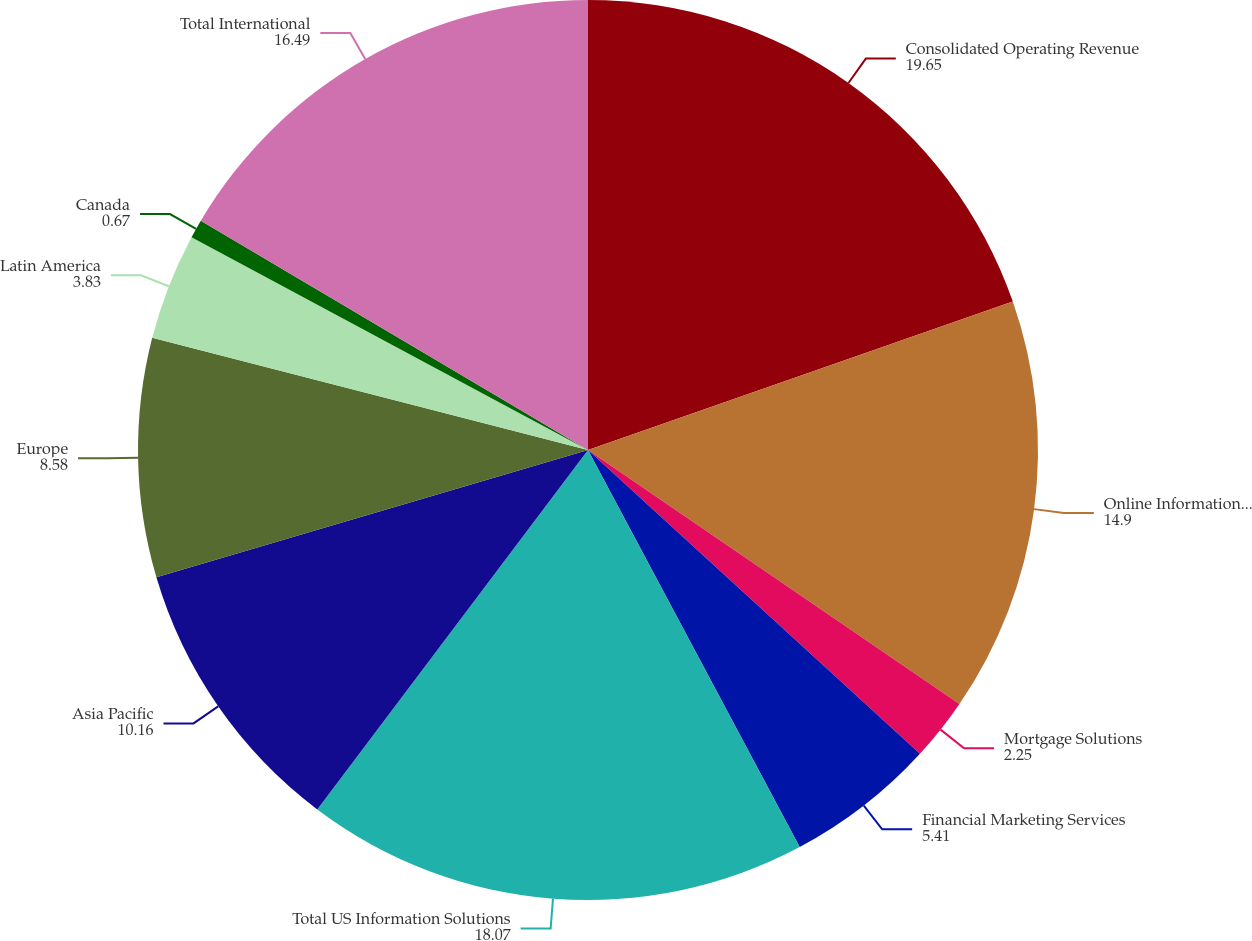Convert chart to OTSL. <chart><loc_0><loc_0><loc_500><loc_500><pie_chart><fcel>Consolidated Operating Revenue<fcel>Online Information Solutions<fcel>Mortgage Solutions<fcel>Financial Marketing Services<fcel>Total US Information Solutions<fcel>Asia Pacific<fcel>Europe<fcel>Latin America<fcel>Canada<fcel>Total International<nl><fcel>19.65%<fcel>14.9%<fcel>2.25%<fcel>5.41%<fcel>18.07%<fcel>10.16%<fcel>8.58%<fcel>3.83%<fcel>0.67%<fcel>16.49%<nl></chart> 